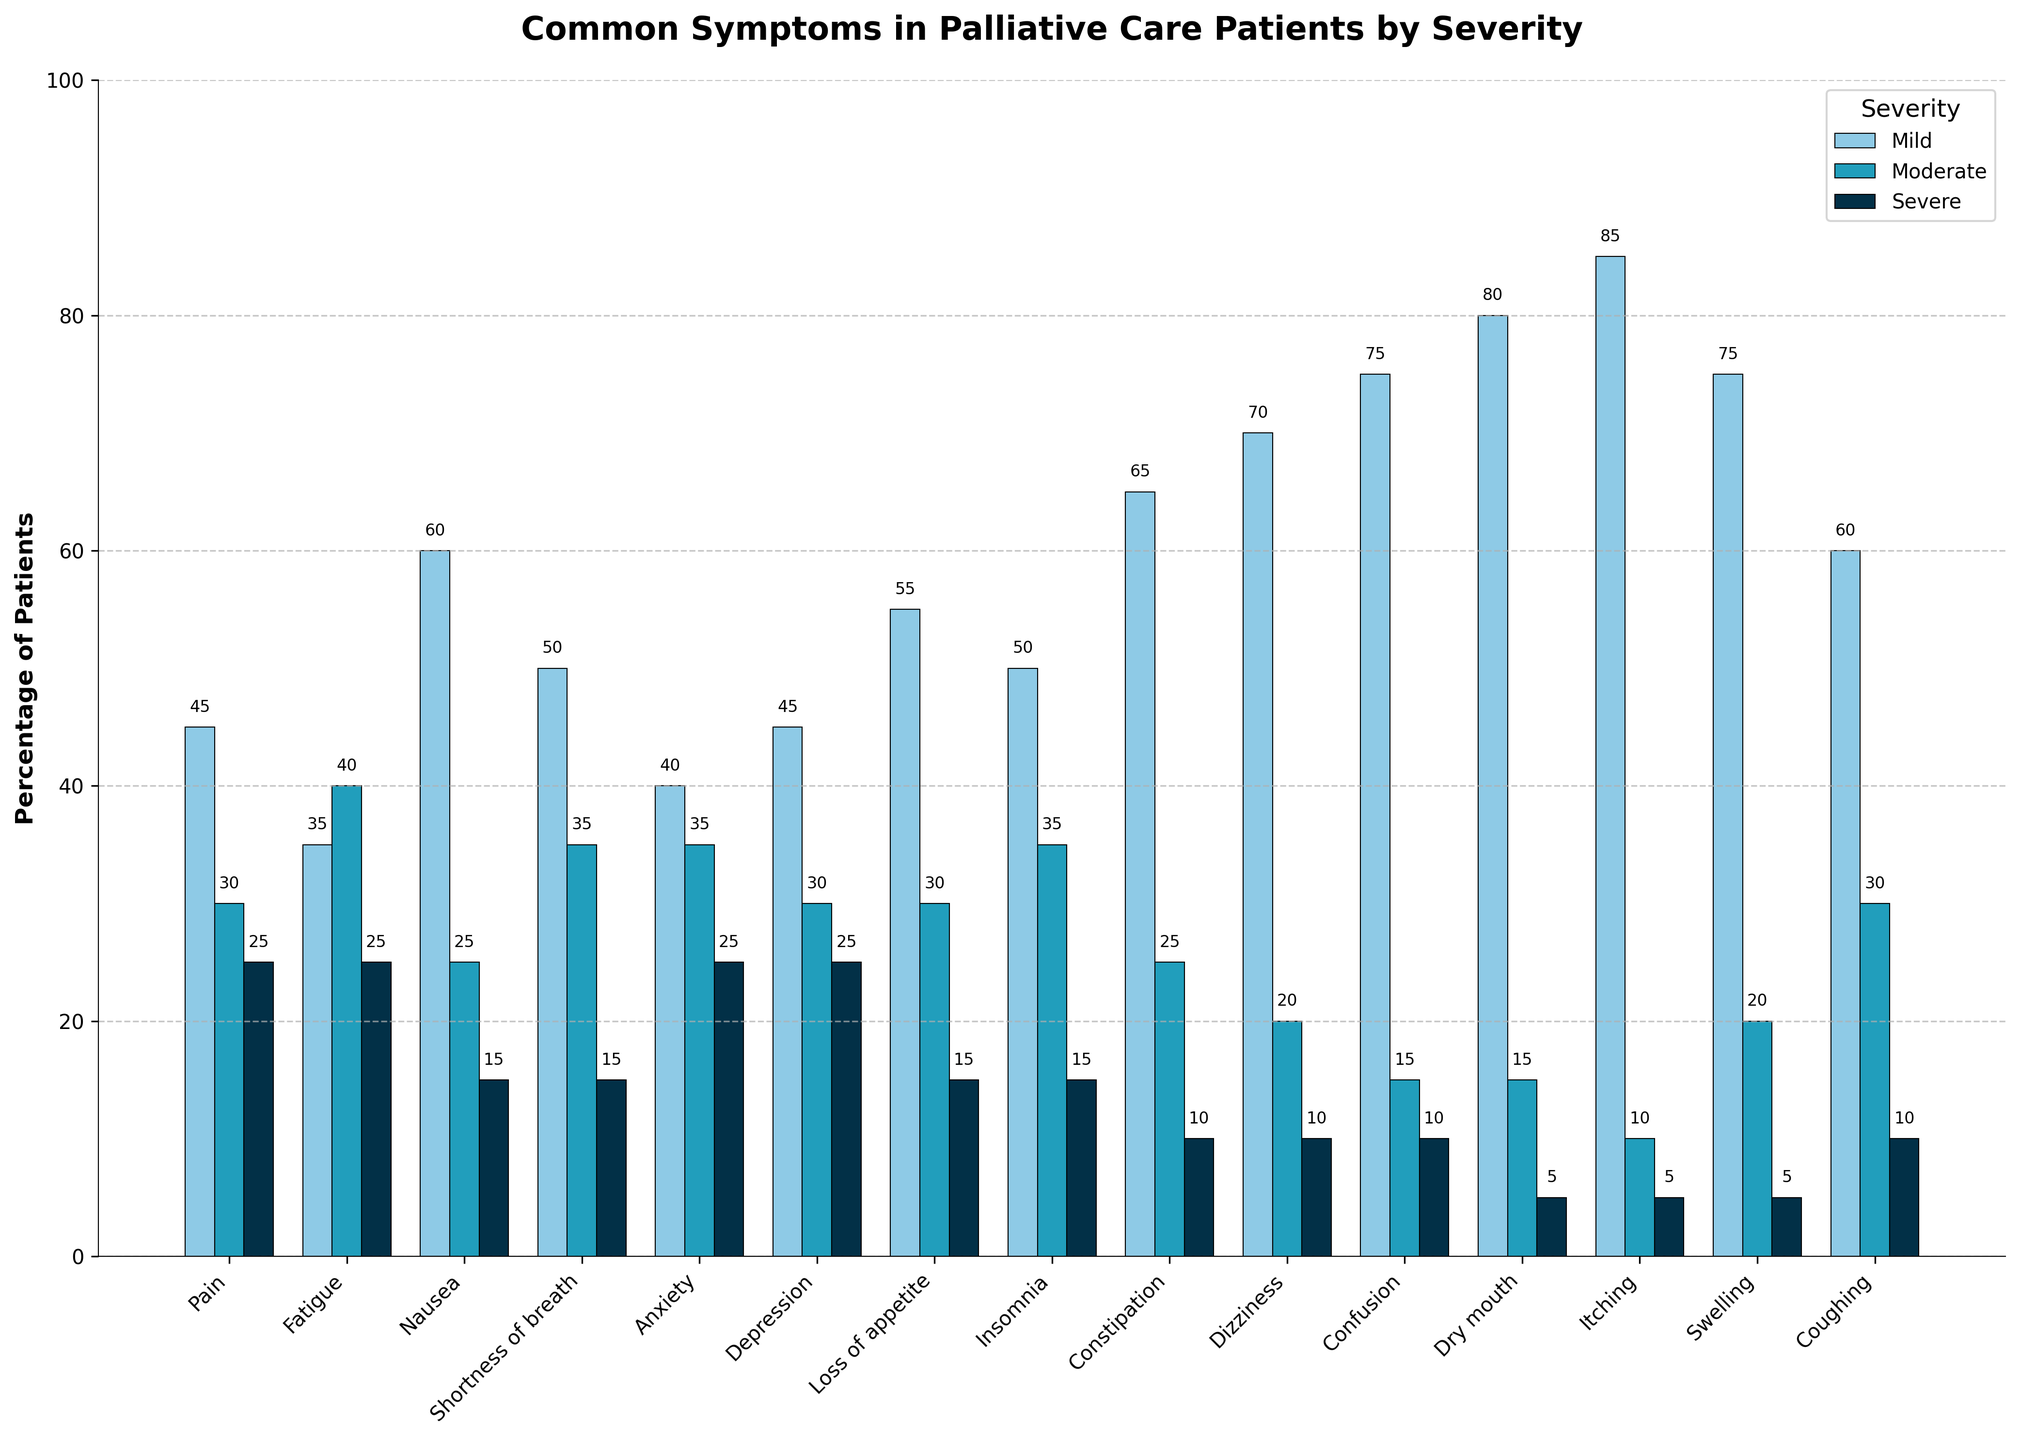Which symptom has the highest percentage of patients experiencing it mildly? The Mild category bars should be examined to find the tallest one. The bar for "Itching" is the highest in this category.
Answer: Itching How many more patients experience dizziness mildly compared to severely? Look at the heights of the Dizziness bars for both the Mild and Severe categories. The Mild value is 70, and the Severe value is 10. Subtract the Severe value from the Mild value: 70 - 10.
Answer: 60 Which symptoms have the same percentage of patients experiencing them moderately? Check the Moderate category bars for symptoms that have the same heights. Both "Anxiety" and "Insomnia" have a Moderate value of 35.
Answer: Anxiety and Insomnia Which symptom has the lowest percentage of patients experiencing it severely and what is the percentage? The Severe category bars should be reviewed to find the shortest one. "Dry mouth" and "Itching" both have the lowest Severe value of 5.
Answer: Dry mouth and Itching, 5 What is the total percentage of patients experiencing any severity of pain? Add the Mild, Moderate, and Severe values for Pain. Pain has 45 (Mild) + 30 (Moderate) + 25 (Severe) = 100.
Answer: 100 Which symptoms have a moderate severity percentage of exactly 25? Examine the Moderate severity bars for their values. "Nausea", "Constipation", and "Coughing" each have a Moderate value of 25.
Answer: Nausea, Constipation, and Coughing What is the average percentage of patients experiencing severe fatigue and severe shortness of breath? Find the Severe values for Fatigue and Shortness of breath, which are 25 and 15 respectively. Average them: (25 + 15) / 2 = 20.
Answer: 20 Compare the number of symptoms with a mild percentage higher than 50 to those with a severe percentage higher than 20. Which is more? Count the symptoms with Mild values greater than 50 and Severe values greater than 20. Mild: "Dry mouth", "Itching", "Swelling", "Confusion", "Dizziness", "Loss of appetite", and "Shortness of breath" (7). Severe: None.
Answer: 7 more in Mild Which symptom has the highest total percentage across all severities? Sum the Mild, Moderate, and Severe values for each symptom and find the maximum. "Pain" has 45 + 30 + 25 = 100, which is the highest.
Answer: Pain What is the difference between the percentage of patients experiencing mild and moderate nausea? Find the Mild and Moderate values for Nausea, which are 60 and 25 respectively. Subtract the Moderate value from the Mild value: 60 - 25.
Answer: 35 